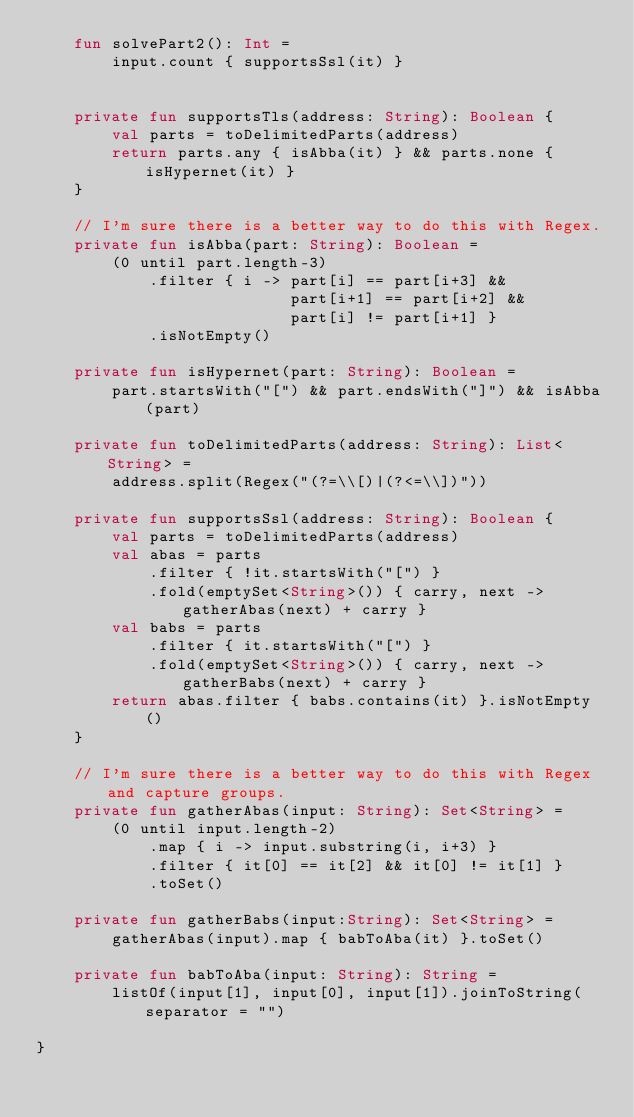Convert code to text. <code><loc_0><loc_0><loc_500><loc_500><_Kotlin_>    fun solvePart2(): Int =
        input.count { supportsSsl(it) }


    private fun supportsTls(address: String): Boolean {
        val parts = toDelimitedParts(address)
        return parts.any { isAbba(it) } && parts.none { isHypernet(it) }
    }

    // I'm sure there is a better way to do this with Regex.
    private fun isAbba(part: String): Boolean =
        (0 until part.length-3)
            .filter { i -> part[i] == part[i+3] &&
                           part[i+1] == part[i+2] &&
                           part[i] != part[i+1] }
            .isNotEmpty()

    private fun isHypernet(part: String): Boolean =
        part.startsWith("[") && part.endsWith("]") && isAbba(part)

    private fun toDelimitedParts(address: String): List<String> =
        address.split(Regex("(?=\\[)|(?<=\\])"))

    private fun supportsSsl(address: String): Boolean {
        val parts = toDelimitedParts(address)
        val abas = parts
            .filter { !it.startsWith("[") }
            .fold(emptySet<String>()) { carry, next -> gatherAbas(next) + carry }
        val babs = parts
            .filter { it.startsWith("[") }
            .fold(emptySet<String>()) { carry, next -> gatherBabs(next) + carry }
        return abas.filter { babs.contains(it) }.isNotEmpty()
    }

    // I'm sure there is a better way to do this with Regex and capture groups.
    private fun gatherAbas(input: String): Set<String> =
        (0 until input.length-2)
            .map { i -> input.substring(i, i+3) }
            .filter { it[0] == it[2] && it[0] != it[1] }
            .toSet()

    private fun gatherBabs(input:String): Set<String> =
        gatherAbas(input).map { babToAba(it) }.toSet()

    private fun babToAba(input: String): String =
        listOf(input[1], input[0], input[1]).joinToString(separator = "")

}
</code> 